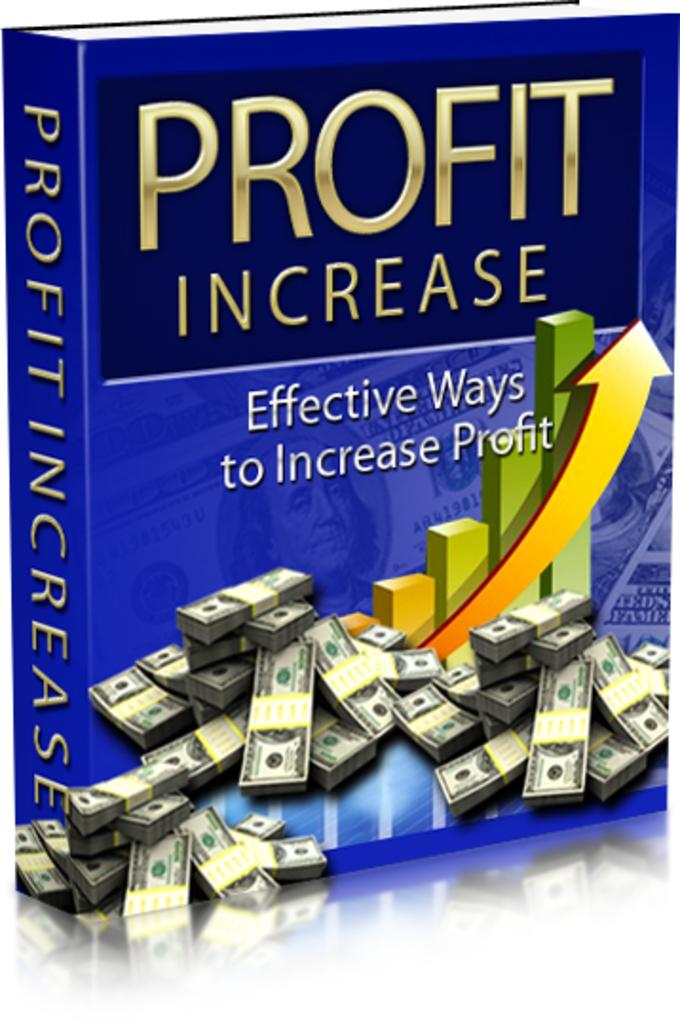Provide a one-sentence caption for the provided image. a blue book with the words Profit Increase on the ftont. 